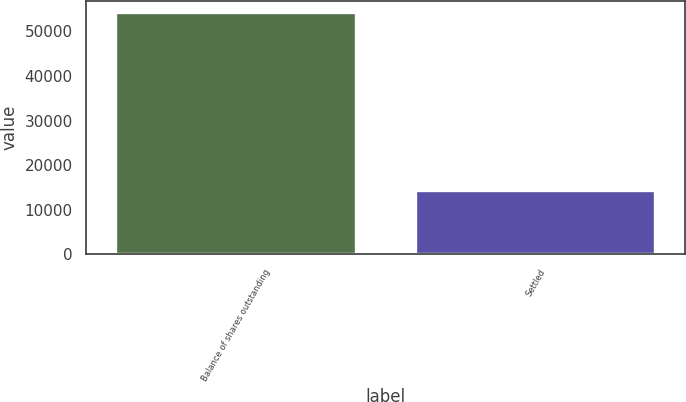Convert chart. <chart><loc_0><loc_0><loc_500><loc_500><bar_chart><fcel>Balance of shares outstanding<fcel>Settled<nl><fcel>54071<fcel>14091<nl></chart> 